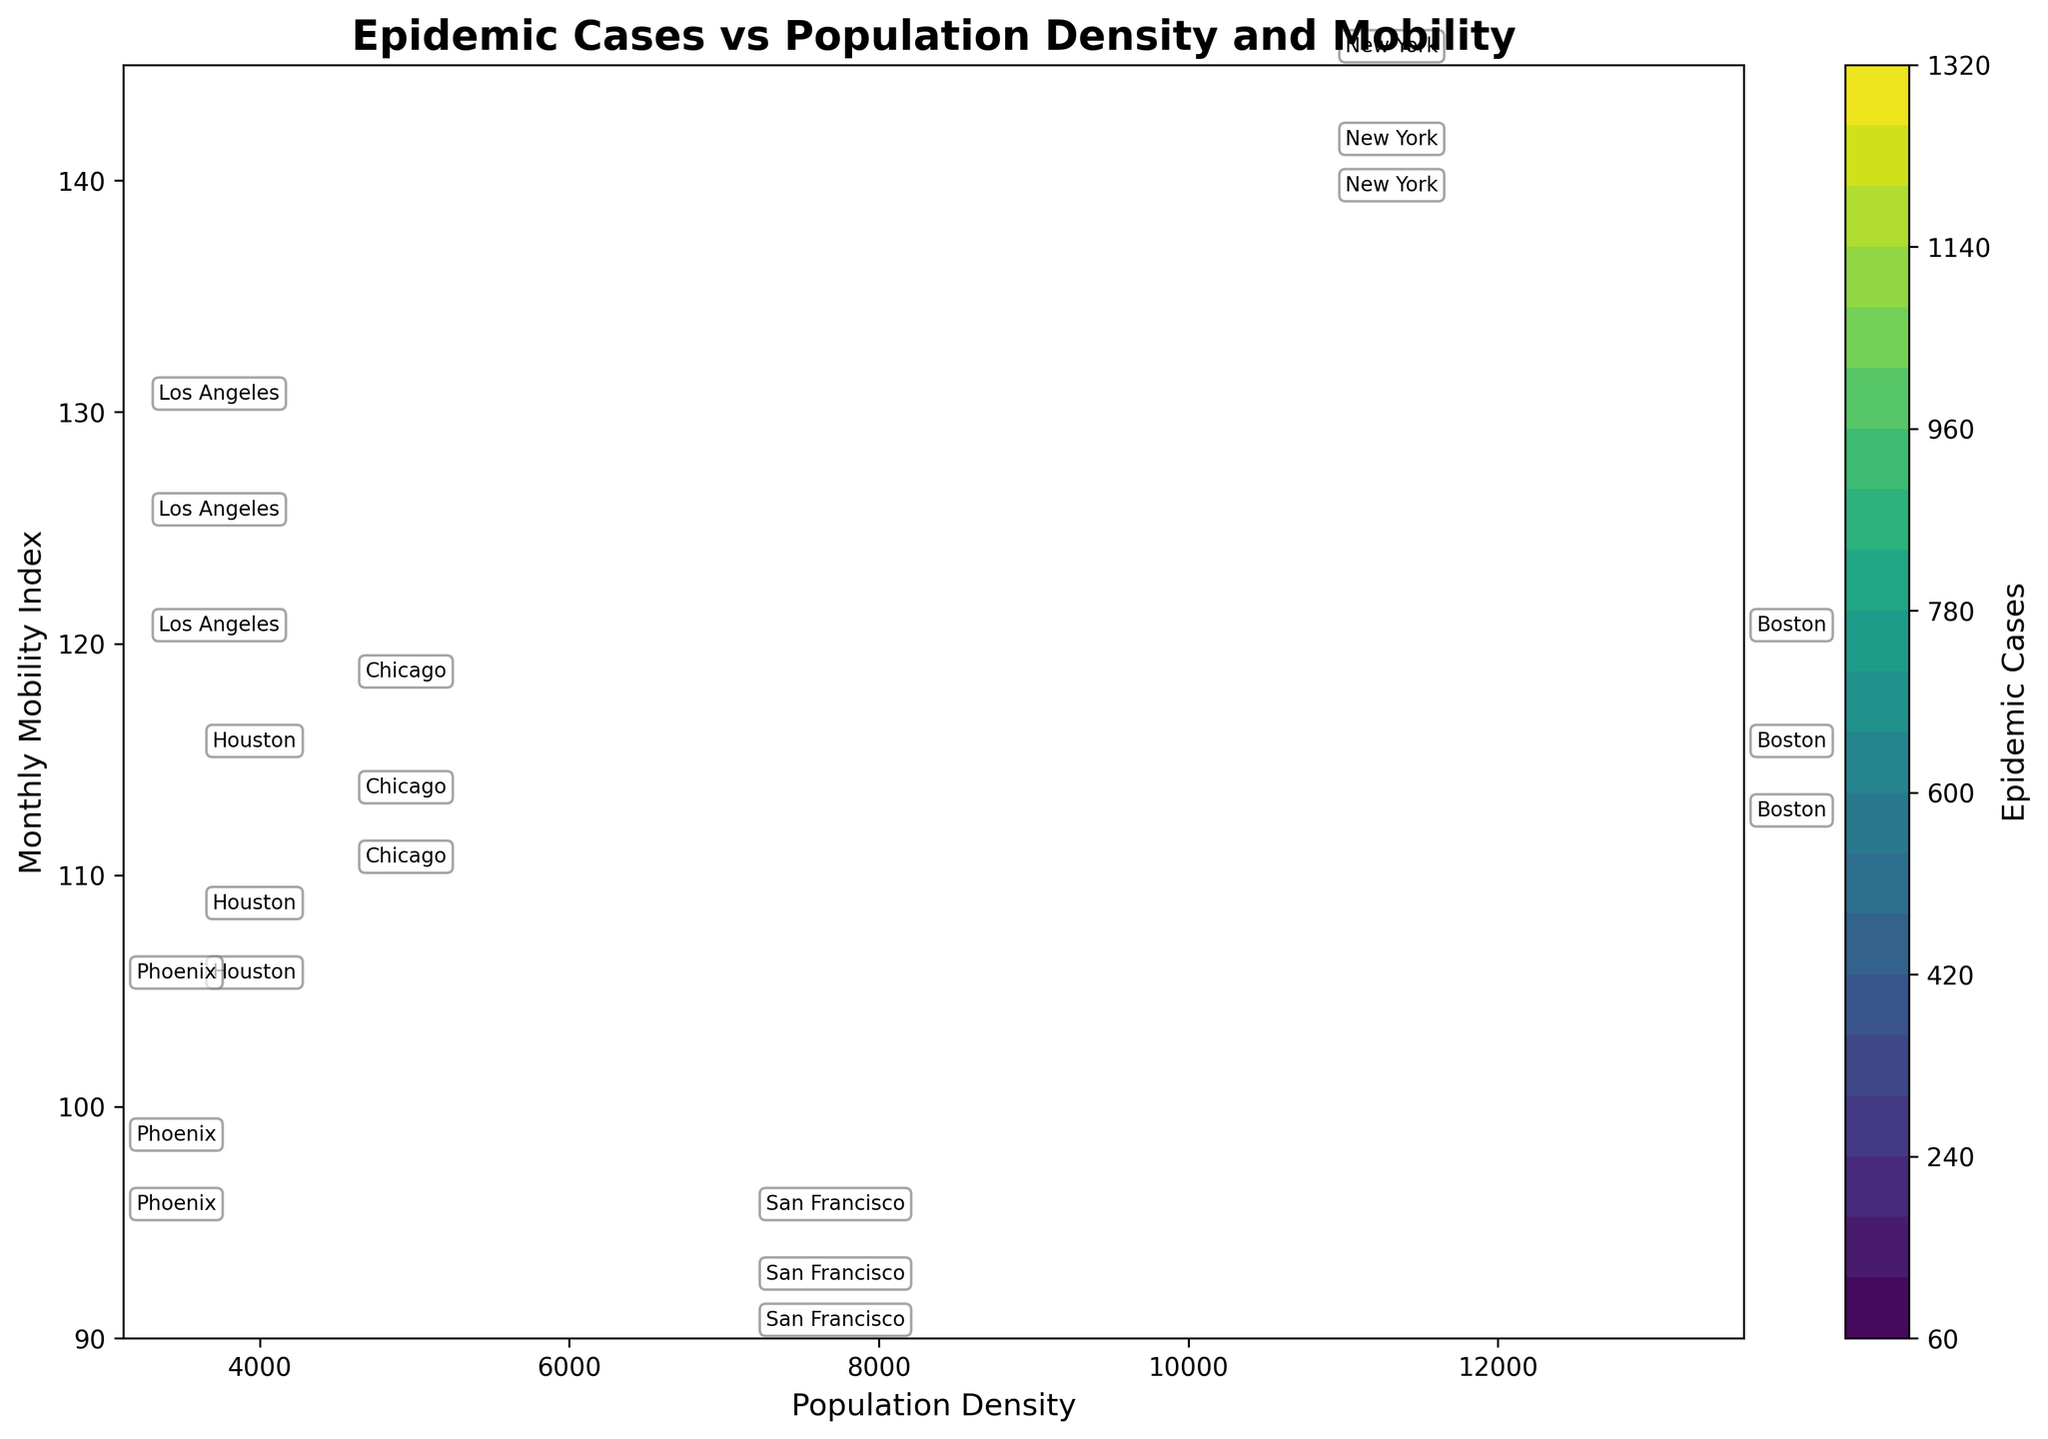What is the title of the contour plot? The title of the contour plot is generally found at the top of the figure. In this case, it reads 'Epidemic Cases vs Population Density and Mobility', indicating it shows the relationship between epidemic cases, population density, and mobility.
Answer: Epidemic Cases vs Population Density and Mobility What are the labels on the x and y axes? The x-axis label represents the population density, while the y-axis label represents the monthly mobility index. These labels help identify the variables plotted on each axis.
Answer: Population Density and Monthly Mobility Index What is the color gradient representing in the contour plot? The color gradient in a contour plot typically represents a numerical value. Here, it is representing the number of epidemic cases. The color bar to the side indicates the color scale with lighter colors representing fewer cases and darker colors indicating more cases.
Answer: Number of epidemic cases Which city has the highest population density? The city with the highest population density will be located furthest to the right on the x-axis of the plot. Here, that city is Boston with a population density of 13590 as labeled on the figure.
Answer: Boston What does a darker region on the contour plot indicate about epidemic cases? In the color bar provided, darker colors indicate higher values. Therefore, darker regions on the contour plot indicate higher numbers of epidemic cases.
Answer: Higher number of epidemic cases How does the epidemic spread in New York from January to March? To understand the progression, we need to observe the labels and their positions for New York over the months. The labels show increasing epidemic cases as both mobility index and time progress, indicating that the number of epidemic cases increases over time in New York.
Answer: It increases Compare the epidemic cases in Los Angeles and Phoenix in January. Which city had more cases? To answer, find the positions of Los Angeles and Phoenix labels in January and compare their color shades. Los Angeles is lighter than Phoenix, indicating that Los Angeles had more epidemic cases in January.
Answer: Los Angeles Which city has the lowest mobility index and in which month? To find this, look at the y-axis and find the lowest point labeled. The city at this point on the plot is San Francisco, especially visible in January with a mobility index of 90.
Answer: San Francisco in January Which city showed the highest epidemic cases across all months? This can be deduced by observing the darkest shaded regions near any of the city labels. Chicago is associated with the darkest region in March, reflecting the highest number of epidemic cases.
Answer: Chicago What trends can be observed between population density and epidemic cases? To observe trends, look at how the epidemic cases change with varying population densities across the plot. Higher population densities often correspond to higher epidemic cases, as shown by the color gradient progressing from lighter shades (fewer cases) to darker shades (more cases).
Answer: Higher population densities tend to have more epidemic cases 